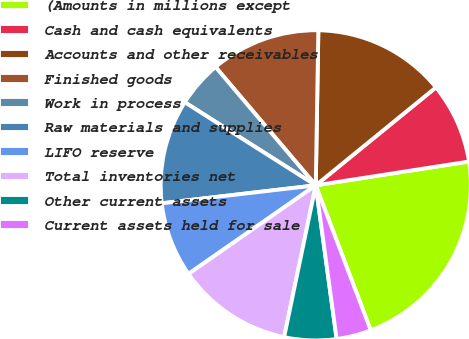Convert chart to OTSL. <chart><loc_0><loc_0><loc_500><loc_500><pie_chart><fcel>(Amounts in millions except<fcel>Cash and cash equivalents<fcel>Accounts and other receivables<fcel>Finished goods<fcel>Work in process<fcel>Raw materials and supplies<fcel>LIFO reserve<fcel>Total inventories net<fcel>Other current assets<fcel>Current assets held for sale<nl><fcel>21.68%<fcel>8.43%<fcel>13.85%<fcel>11.45%<fcel>4.82%<fcel>10.84%<fcel>7.83%<fcel>12.05%<fcel>5.42%<fcel>3.62%<nl></chart> 